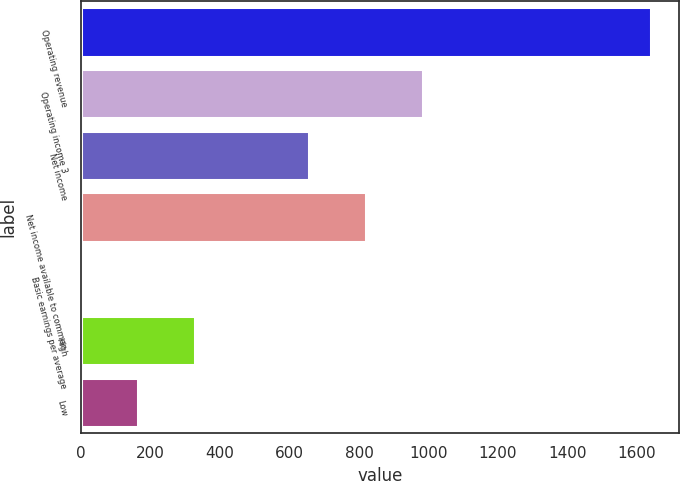Convert chart to OTSL. <chart><loc_0><loc_0><loc_500><loc_500><bar_chart><fcel>Operating revenue<fcel>Operating income 3<fcel>Net income<fcel>Net income available to common<fcel>Basic earnings per average<fcel>High<fcel>Low<nl><fcel>1640<fcel>984.1<fcel>656.16<fcel>820.13<fcel>0.28<fcel>328.22<fcel>164.25<nl></chart> 